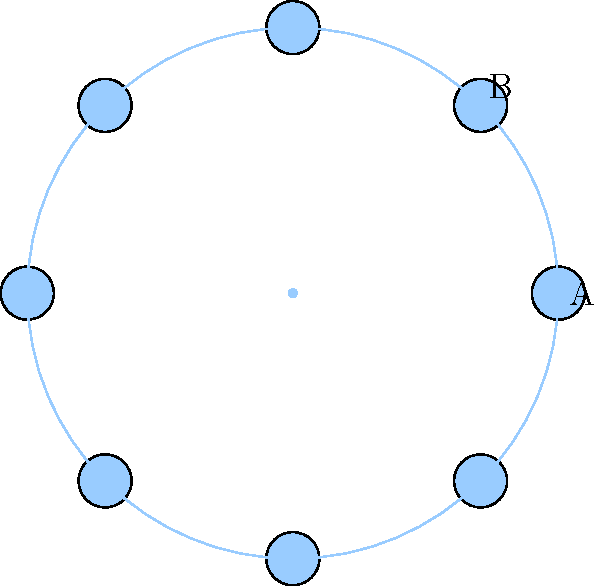For a roundtable peace conference, seats are arranged in a regular octagon as shown. If the distance between adjacent seats (represented by the chord AB) is 1.5 meters, what is the maximum number of additional seats that can be added to the table while maintaining this minimum distance between all adjacent seats? Let's approach this step-by-step:

1) First, we need to calculate the radius of the circle circumscribing the octagon. We can do this using the formula for the chord length in a regular polygon:

   $chord = 2R \sin(\frac{\pi}{n})$

   Where $R$ is the radius and $n$ is the number of sides.

2) We know that $chord (AB) = 1.5$ and $n = 8$. Let's substitute:

   $1.5 = 2R \sin(\frac{\pi}{8})$

3) Solving for $R$:

   $R = \frac{1.5}{2\sin(\frac{\pi}{8})} \approx 1.85$ meters

4) Now, we need to find the maximum number of seats that can fit on this circle. The arc length between two seats should be at least 1.5 meters.

5) The circumference of the circle is $2\pi R \approx 11.62$ meters.

6) The maximum number of seats is the floor of the circumference divided by 1.5:

   $\lfloor \frac{11.62}{1.5} \rfloor = 7$

7) Since we already have 8 seats, we can't add any more seats while maintaining the minimum distance.
Answer: 0 additional seats 